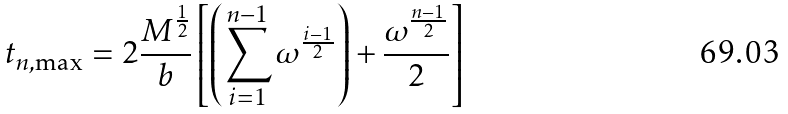<formula> <loc_0><loc_0><loc_500><loc_500>t _ { n , \max } = 2 \frac { M ^ { \frac { 1 } { 2 } } } { b } \left [ \left ( \sum _ { i = 1 } ^ { n - 1 } \omega ^ { \frac { i - 1 } { 2 } } \right ) + \frac { \omega ^ { \frac { n - 1 } { 2 } } } { 2 } \right ]</formula> 